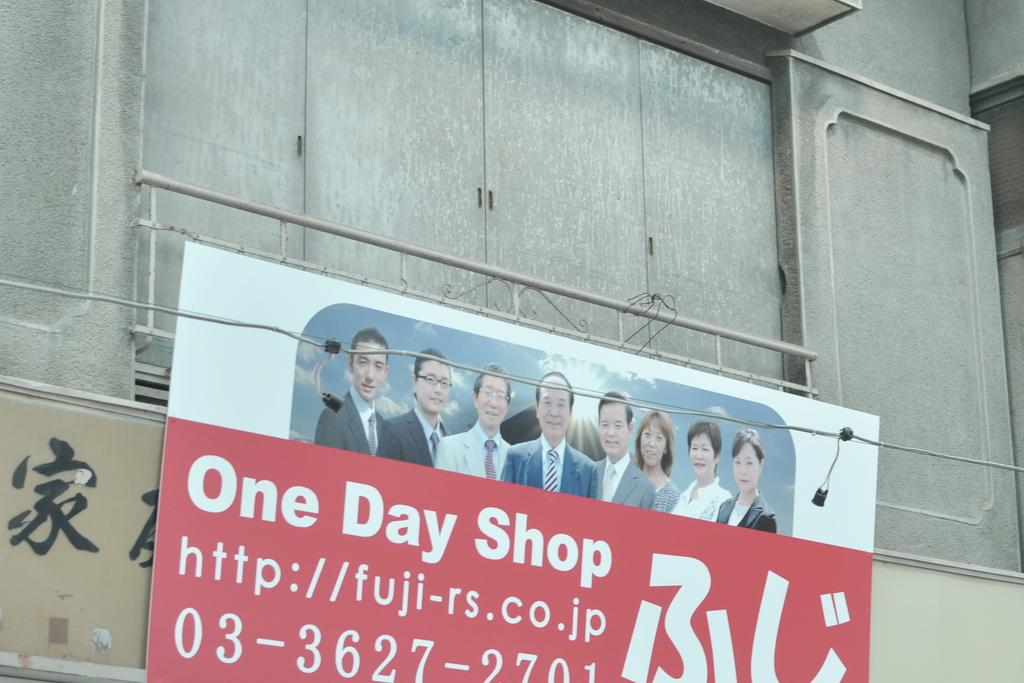<image>
Present a compact description of the photo's key features. Sign on a wall which says ONE DAY SHOP. 